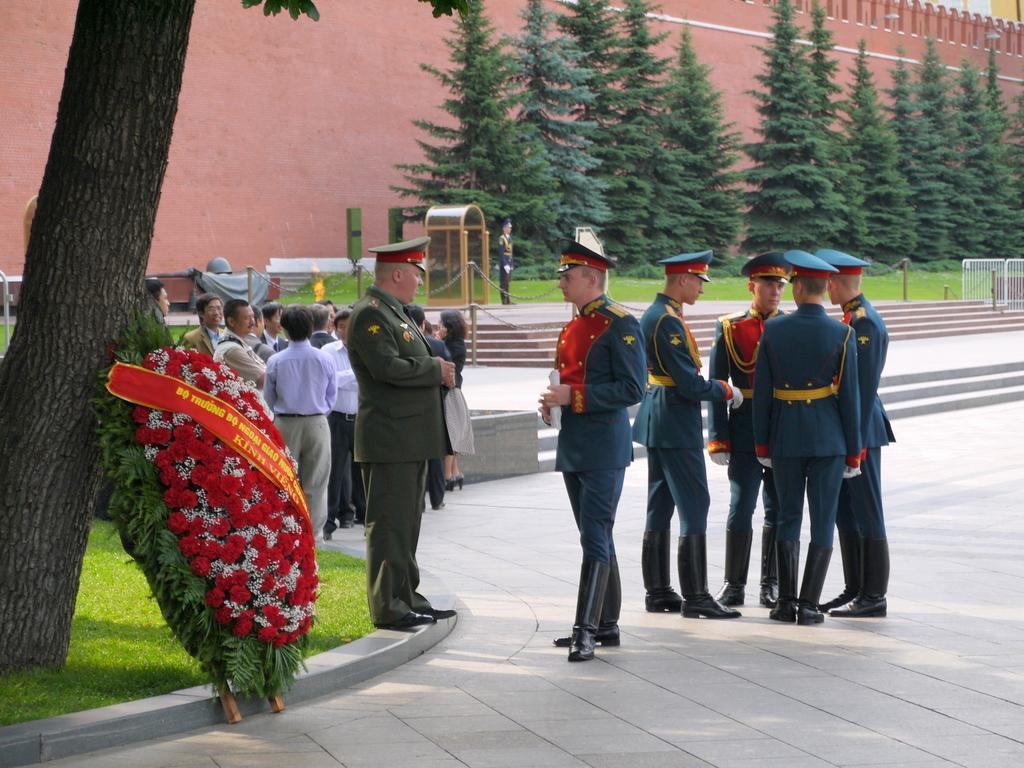How would you summarize this image in a sentence or two? In this image I can see number of persons are standing and few of them are wearing uniforms. I can see a huge flower bouquet, few stairs, few trees which are green in color, the railing and a huge wall which is brown in color. 